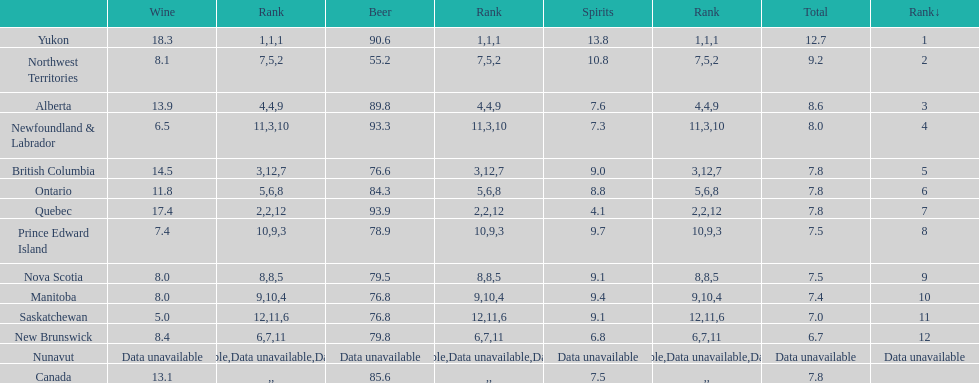I'm looking to parse the entire table for insights. Could you assist me with that? {'header': ['', 'Wine', 'Rank', 'Beer', 'Rank', 'Spirits', 'Rank', 'Total', 'Rank↓'], 'rows': [['Yukon', '18.3', '1', '90.6', '1', '13.8', '1', '12.7', '1'], ['Northwest Territories', '8.1', '7', '55.2', '5', '10.8', '2', '9.2', '2'], ['Alberta', '13.9', '4', '89.8', '4', '7.6', '9', '8.6', '3'], ['Newfoundland & Labrador', '6.5', '11', '93.3', '3', '7.3', '10', '8.0', '4'], ['British Columbia', '14.5', '3', '76.6', '12', '9.0', '7', '7.8', '5'], ['Ontario', '11.8', '5', '84.3', '6', '8.8', '8', '7.8', '6'], ['Quebec', '17.4', '2', '93.9', '2', '4.1', '12', '7.8', '7'], ['Prince Edward Island', '7.4', '10', '78.9', '9', '9.7', '3', '7.5', '8'], ['Nova Scotia', '8.0', '8', '79.5', '8', '9.1', '5', '7.5', '9'], ['Manitoba', '8.0', '9', '76.8', '10', '9.4', '4', '7.4', '10'], ['Saskatchewan', '5.0', '12', '76.8', '11', '9.1', '6', '7.0', '11'], ['New Brunswick', '8.4', '6', '79.8', '7', '6.8', '11', '6.7', '12'], ['Nunavut', 'Data unavailable', 'Data unavailable', 'Data unavailable', 'Data unavailable', 'Data unavailable', 'Data unavailable', 'Data unavailable', 'Data unavailable'], ['Canada', '13.1', '', '85.6', '', '7.5', '', '7.8', '']]} 0? 5. 